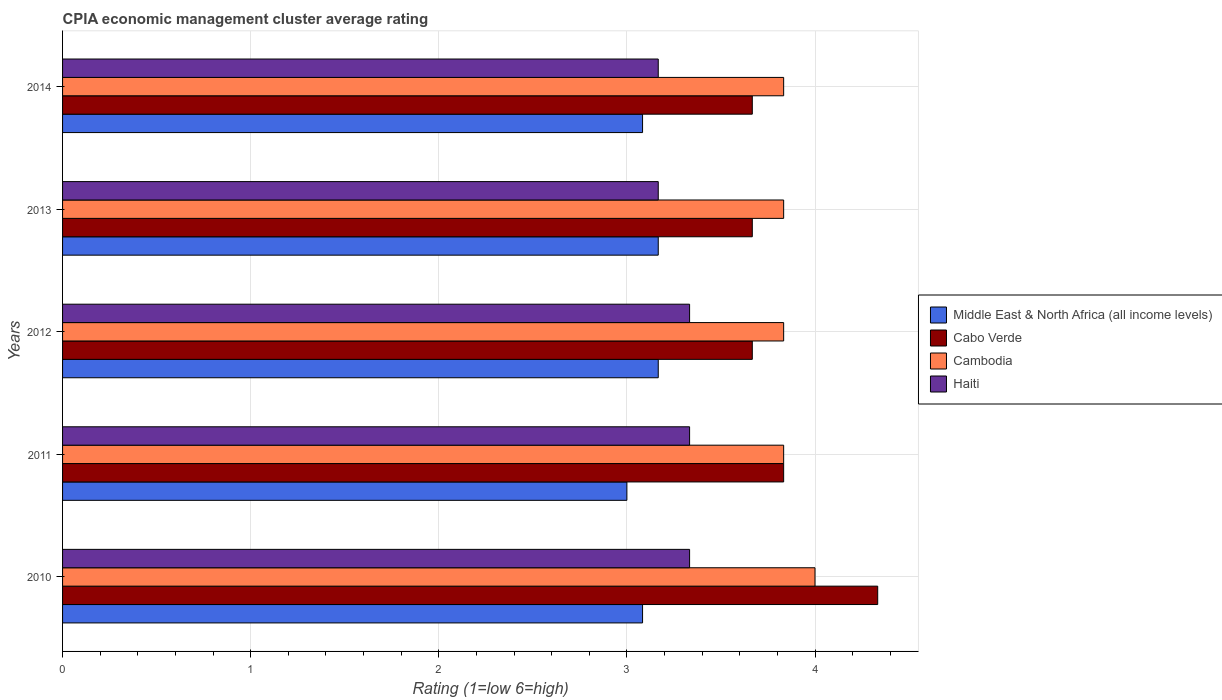Are the number of bars per tick equal to the number of legend labels?
Your answer should be very brief. Yes. Are the number of bars on each tick of the Y-axis equal?
Your answer should be very brief. Yes. How many bars are there on the 5th tick from the top?
Offer a very short reply. 4. How many bars are there on the 4th tick from the bottom?
Provide a succinct answer. 4. What is the label of the 4th group of bars from the top?
Offer a terse response. 2011. In how many cases, is the number of bars for a given year not equal to the number of legend labels?
Ensure brevity in your answer.  0. What is the CPIA rating in Middle East & North Africa (all income levels) in 2014?
Provide a succinct answer. 3.08. Across all years, what is the minimum CPIA rating in Middle East & North Africa (all income levels)?
Keep it short and to the point. 3. What is the total CPIA rating in Haiti in the graph?
Offer a very short reply. 16.33. What is the difference between the CPIA rating in Cabo Verde in 2013 and that in 2014?
Offer a terse response. 0. What is the difference between the CPIA rating in Cambodia in 2011 and the CPIA rating in Haiti in 2013?
Your response must be concise. 0.67. What is the average CPIA rating in Haiti per year?
Keep it short and to the point. 3.27. In the year 2010, what is the difference between the CPIA rating in Haiti and CPIA rating in Middle East & North Africa (all income levels)?
Your answer should be compact. 0.25. What is the ratio of the CPIA rating in Middle East & North Africa (all income levels) in 2010 to that in 2012?
Your answer should be very brief. 0.97. Is the CPIA rating in Haiti in 2010 less than that in 2013?
Offer a terse response. No. Is the difference between the CPIA rating in Haiti in 2010 and 2013 greater than the difference between the CPIA rating in Middle East & North Africa (all income levels) in 2010 and 2013?
Your response must be concise. Yes. What is the difference between the highest and the second highest CPIA rating in Cambodia?
Keep it short and to the point. 0.17. What is the difference between the highest and the lowest CPIA rating in Cabo Verde?
Give a very brief answer. 0.67. Is it the case that in every year, the sum of the CPIA rating in Haiti and CPIA rating in Cabo Verde is greater than the sum of CPIA rating in Cambodia and CPIA rating in Middle East & North Africa (all income levels)?
Your answer should be compact. Yes. What does the 3rd bar from the top in 2011 represents?
Make the answer very short. Cabo Verde. What does the 2nd bar from the bottom in 2014 represents?
Your response must be concise. Cabo Verde. How many bars are there?
Ensure brevity in your answer.  20. How many years are there in the graph?
Your answer should be compact. 5. What is the difference between two consecutive major ticks on the X-axis?
Keep it short and to the point. 1. Are the values on the major ticks of X-axis written in scientific E-notation?
Offer a terse response. No. Does the graph contain any zero values?
Give a very brief answer. No. How are the legend labels stacked?
Your response must be concise. Vertical. What is the title of the graph?
Offer a very short reply. CPIA economic management cluster average rating. Does "Albania" appear as one of the legend labels in the graph?
Offer a very short reply. No. What is the label or title of the Y-axis?
Keep it short and to the point. Years. What is the Rating (1=low 6=high) of Middle East & North Africa (all income levels) in 2010?
Ensure brevity in your answer.  3.08. What is the Rating (1=low 6=high) of Cabo Verde in 2010?
Provide a succinct answer. 4.33. What is the Rating (1=low 6=high) of Haiti in 2010?
Keep it short and to the point. 3.33. What is the Rating (1=low 6=high) in Middle East & North Africa (all income levels) in 2011?
Provide a short and direct response. 3. What is the Rating (1=low 6=high) of Cabo Verde in 2011?
Make the answer very short. 3.83. What is the Rating (1=low 6=high) of Cambodia in 2011?
Offer a terse response. 3.83. What is the Rating (1=low 6=high) of Haiti in 2011?
Ensure brevity in your answer.  3.33. What is the Rating (1=low 6=high) of Middle East & North Africa (all income levels) in 2012?
Your answer should be very brief. 3.17. What is the Rating (1=low 6=high) in Cabo Verde in 2012?
Provide a short and direct response. 3.67. What is the Rating (1=low 6=high) of Cambodia in 2012?
Your response must be concise. 3.83. What is the Rating (1=low 6=high) in Haiti in 2012?
Give a very brief answer. 3.33. What is the Rating (1=low 6=high) in Middle East & North Africa (all income levels) in 2013?
Ensure brevity in your answer.  3.17. What is the Rating (1=low 6=high) of Cabo Verde in 2013?
Keep it short and to the point. 3.67. What is the Rating (1=low 6=high) of Cambodia in 2013?
Offer a terse response. 3.83. What is the Rating (1=low 6=high) in Haiti in 2013?
Give a very brief answer. 3.17. What is the Rating (1=low 6=high) of Middle East & North Africa (all income levels) in 2014?
Keep it short and to the point. 3.08. What is the Rating (1=low 6=high) in Cabo Verde in 2014?
Offer a very short reply. 3.67. What is the Rating (1=low 6=high) in Cambodia in 2014?
Your answer should be compact. 3.83. What is the Rating (1=low 6=high) in Haiti in 2014?
Your response must be concise. 3.17. Across all years, what is the maximum Rating (1=low 6=high) of Middle East & North Africa (all income levels)?
Keep it short and to the point. 3.17. Across all years, what is the maximum Rating (1=low 6=high) of Cabo Verde?
Ensure brevity in your answer.  4.33. Across all years, what is the maximum Rating (1=low 6=high) in Haiti?
Provide a short and direct response. 3.33. Across all years, what is the minimum Rating (1=low 6=high) in Cabo Verde?
Give a very brief answer. 3.67. Across all years, what is the minimum Rating (1=low 6=high) in Cambodia?
Your answer should be compact. 3.83. Across all years, what is the minimum Rating (1=low 6=high) in Haiti?
Offer a terse response. 3.17. What is the total Rating (1=low 6=high) of Cabo Verde in the graph?
Offer a terse response. 19.17. What is the total Rating (1=low 6=high) in Cambodia in the graph?
Give a very brief answer. 19.33. What is the total Rating (1=low 6=high) of Haiti in the graph?
Make the answer very short. 16.33. What is the difference between the Rating (1=low 6=high) in Middle East & North Africa (all income levels) in 2010 and that in 2011?
Your answer should be compact. 0.08. What is the difference between the Rating (1=low 6=high) of Cabo Verde in 2010 and that in 2011?
Provide a short and direct response. 0.5. What is the difference between the Rating (1=low 6=high) in Cambodia in 2010 and that in 2011?
Provide a succinct answer. 0.17. What is the difference between the Rating (1=low 6=high) in Haiti in 2010 and that in 2011?
Offer a very short reply. 0. What is the difference between the Rating (1=low 6=high) in Middle East & North Africa (all income levels) in 2010 and that in 2012?
Make the answer very short. -0.08. What is the difference between the Rating (1=low 6=high) in Cabo Verde in 2010 and that in 2012?
Provide a succinct answer. 0.67. What is the difference between the Rating (1=low 6=high) of Cambodia in 2010 and that in 2012?
Provide a succinct answer. 0.17. What is the difference between the Rating (1=low 6=high) in Haiti in 2010 and that in 2012?
Make the answer very short. 0. What is the difference between the Rating (1=low 6=high) of Middle East & North Africa (all income levels) in 2010 and that in 2013?
Ensure brevity in your answer.  -0.08. What is the difference between the Rating (1=low 6=high) in Cabo Verde in 2010 and that in 2013?
Keep it short and to the point. 0.67. What is the difference between the Rating (1=low 6=high) of Haiti in 2010 and that in 2013?
Offer a very short reply. 0.17. What is the difference between the Rating (1=low 6=high) of Cambodia in 2010 and that in 2014?
Ensure brevity in your answer.  0.17. What is the difference between the Rating (1=low 6=high) of Haiti in 2010 and that in 2014?
Your answer should be very brief. 0.17. What is the difference between the Rating (1=low 6=high) in Cambodia in 2011 and that in 2012?
Offer a very short reply. 0. What is the difference between the Rating (1=low 6=high) of Haiti in 2011 and that in 2012?
Your response must be concise. 0. What is the difference between the Rating (1=low 6=high) in Cabo Verde in 2011 and that in 2013?
Offer a very short reply. 0.17. What is the difference between the Rating (1=low 6=high) of Cambodia in 2011 and that in 2013?
Your answer should be compact. 0. What is the difference between the Rating (1=low 6=high) in Middle East & North Africa (all income levels) in 2011 and that in 2014?
Offer a very short reply. -0.08. What is the difference between the Rating (1=low 6=high) of Cabo Verde in 2011 and that in 2014?
Offer a terse response. 0.17. What is the difference between the Rating (1=low 6=high) of Haiti in 2011 and that in 2014?
Provide a short and direct response. 0.17. What is the difference between the Rating (1=low 6=high) in Middle East & North Africa (all income levels) in 2012 and that in 2013?
Provide a succinct answer. 0. What is the difference between the Rating (1=low 6=high) in Cabo Verde in 2012 and that in 2013?
Offer a very short reply. 0. What is the difference between the Rating (1=low 6=high) in Haiti in 2012 and that in 2013?
Offer a terse response. 0.17. What is the difference between the Rating (1=low 6=high) in Middle East & North Africa (all income levels) in 2012 and that in 2014?
Your answer should be very brief. 0.08. What is the difference between the Rating (1=low 6=high) in Cabo Verde in 2012 and that in 2014?
Ensure brevity in your answer.  0. What is the difference between the Rating (1=low 6=high) of Haiti in 2012 and that in 2014?
Your answer should be very brief. 0.17. What is the difference between the Rating (1=low 6=high) of Middle East & North Africa (all income levels) in 2013 and that in 2014?
Your answer should be very brief. 0.08. What is the difference between the Rating (1=low 6=high) of Cambodia in 2013 and that in 2014?
Keep it short and to the point. 0. What is the difference between the Rating (1=low 6=high) of Haiti in 2013 and that in 2014?
Offer a terse response. -0. What is the difference between the Rating (1=low 6=high) in Middle East & North Africa (all income levels) in 2010 and the Rating (1=low 6=high) in Cabo Verde in 2011?
Ensure brevity in your answer.  -0.75. What is the difference between the Rating (1=low 6=high) in Middle East & North Africa (all income levels) in 2010 and the Rating (1=low 6=high) in Cambodia in 2011?
Your answer should be very brief. -0.75. What is the difference between the Rating (1=low 6=high) of Middle East & North Africa (all income levels) in 2010 and the Rating (1=low 6=high) of Haiti in 2011?
Keep it short and to the point. -0.25. What is the difference between the Rating (1=low 6=high) of Cabo Verde in 2010 and the Rating (1=low 6=high) of Cambodia in 2011?
Your answer should be compact. 0.5. What is the difference between the Rating (1=low 6=high) in Cabo Verde in 2010 and the Rating (1=low 6=high) in Haiti in 2011?
Keep it short and to the point. 1. What is the difference between the Rating (1=low 6=high) in Cambodia in 2010 and the Rating (1=low 6=high) in Haiti in 2011?
Your answer should be compact. 0.67. What is the difference between the Rating (1=low 6=high) of Middle East & North Africa (all income levels) in 2010 and the Rating (1=low 6=high) of Cabo Verde in 2012?
Provide a succinct answer. -0.58. What is the difference between the Rating (1=low 6=high) in Middle East & North Africa (all income levels) in 2010 and the Rating (1=low 6=high) in Cambodia in 2012?
Give a very brief answer. -0.75. What is the difference between the Rating (1=low 6=high) in Cabo Verde in 2010 and the Rating (1=low 6=high) in Cambodia in 2012?
Your response must be concise. 0.5. What is the difference between the Rating (1=low 6=high) of Cabo Verde in 2010 and the Rating (1=low 6=high) of Haiti in 2012?
Ensure brevity in your answer.  1. What is the difference between the Rating (1=low 6=high) in Cambodia in 2010 and the Rating (1=low 6=high) in Haiti in 2012?
Ensure brevity in your answer.  0.67. What is the difference between the Rating (1=low 6=high) of Middle East & North Africa (all income levels) in 2010 and the Rating (1=low 6=high) of Cabo Verde in 2013?
Keep it short and to the point. -0.58. What is the difference between the Rating (1=low 6=high) of Middle East & North Africa (all income levels) in 2010 and the Rating (1=low 6=high) of Cambodia in 2013?
Your response must be concise. -0.75. What is the difference between the Rating (1=low 6=high) of Middle East & North Africa (all income levels) in 2010 and the Rating (1=low 6=high) of Haiti in 2013?
Your answer should be compact. -0.08. What is the difference between the Rating (1=low 6=high) of Cabo Verde in 2010 and the Rating (1=low 6=high) of Cambodia in 2013?
Provide a short and direct response. 0.5. What is the difference between the Rating (1=low 6=high) in Cabo Verde in 2010 and the Rating (1=low 6=high) in Haiti in 2013?
Provide a succinct answer. 1.17. What is the difference between the Rating (1=low 6=high) in Cambodia in 2010 and the Rating (1=low 6=high) in Haiti in 2013?
Your response must be concise. 0.83. What is the difference between the Rating (1=low 6=high) of Middle East & North Africa (all income levels) in 2010 and the Rating (1=low 6=high) of Cabo Verde in 2014?
Make the answer very short. -0.58. What is the difference between the Rating (1=low 6=high) of Middle East & North Africa (all income levels) in 2010 and the Rating (1=low 6=high) of Cambodia in 2014?
Offer a very short reply. -0.75. What is the difference between the Rating (1=low 6=high) in Middle East & North Africa (all income levels) in 2010 and the Rating (1=low 6=high) in Haiti in 2014?
Provide a succinct answer. -0.08. What is the difference between the Rating (1=low 6=high) in Cabo Verde in 2010 and the Rating (1=low 6=high) in Cambodia in 2014?
Keep it short and to the point. 0.5. What is the difference between the Rating (1=low 6=high) in Cabo Verde in 2010 and the Rating (1=low 6=high) in Haiti in 2014?
Your answer should be compact. 1.17. What is the difference between the Rating (1=low 6=high) of Middle East & North Africa (all income levels) in 2011 and the Rating (1=low 6=high) of Cabo Verde in 2012?
Your answer should be compact. -0.67. What is the difference between the Rating (1=low 6=high) of Middle East & North Africa (all income levels) in 2011 and the Rating (1=low 6=high) of Cambodia in 2012?
Your response must be concise. -0.83. What is the difference between the Rating (1=low 6=high) in Middle East & North Africa (all income levels) in 2011 and the Rating (1=low 6=high) in Haiti in 2012?
Make the answer very short. -0.33. What is the difference between the Rating (1=low 6=high) of Cabo Verde in 2011 and the Rating (1=low 6=high) of Cambodia in 2012?
Offer a very short reply. 0. What is the difference between the Rating (1=low 6=high) of Cabo Verde in 2011 and the Rating (1=low 6=high) of Haiti in 2012?
Keep it short and to the point. 0.5. What is the difference between the Rating (1=low 6=high) in Cambodia in 2011 and the Rating (1=low 6=high) in Haiti in 2012?
Your answer should be very brief. 0.5. What is the difference between the Rating (1=low 6=high) of Middle East & North Africa (all income levels) in 2011 and the Rating (1=low 6=high) of Cambodia in 2013?
Offer a terse response. -0.83. What is the difference between the Rating (1=low 6=high) of Middle East & North Africa (all income levels) in 2011 and the Rating (1=low 6=high) of Haiti in 2013?
Make the answer very short. -0.17. What is the difference between the Rating (1=low 6=high) of Middle East & North Africa (all income levels) in 2011 and the Rating (1=low 6=high) of Cabo Verde in 2014?
Offer a terse response. -0.67. What is the difference between the Rating (1=low 6=high) of Middle East & North Africa (all income levels) in 2011 and the Rating (1=low 6=high) of Haiti in 2014?
Provide a succinct answer. -0.17. What is the difference between the Rating (1=low 6=high) in Cabo Verde in 2011 and the Rating (1=low 6=high) in Haiti in 2014?
Provide a short and direct response. 0.67. What is the difference between the Rating (1=low 6=high) in Middle East & North Africa (all income levels) in 2012 and the Rating (1=low 6=high) in Cabo Verde in 2013?
Your answer should be very brief. -0.5. What is the difference between the Rating (1=low 6=high) of Cabo Verde in 2012 and the Rating (1=low 6=high) of Haiti in 2013?
Your response must be concise. 0.5. What is the difference between the Rating (1=low 6=high) of Cambodia in 2012 and the Rating (1=low 6=high) of Haiti in 2013?
Provide a short and direct response. 0.67. What is the difference between the Rating (1=low 6=high) in Middle East & North Africa (all income levels) in 2012 and the Rating (1=low 6=high) in Cabo Verde in 2014?
Your answer should be very brief. -0.5. What is the difference between the Rating (1=low 6=high) of Cabo Verde in 2012 and the Rating (1=low 6=high) of Cambodia in 2014?
Offer a terse response. -0.17. What is the difference between the Rating (1=low 6=high) in Cambodia in 2012 and the Rating (1=low 6=high) in Haiti in 2014?
Your response must be concise. 0.67. What is the difference between the Rating (1=low 6=high) of Middle East & North Africa (all income levels) in 2013 and the Rating (1=low 6=high) of Cambodia in 2014?
Your answer should be very brief. -0.67. What is the average Rating (1=low 6=high) in Cabo Verde per year?
Give a very brief answer. 3.83. What is the average Rating (1=low 6=high) of Cambodia per year?
Offer a very short reply. 3.87. What is the average Rating (1=low 6=high) in Haiti per year?
Ensure brevity in your answer.  3.27. In the year 2010, what is the difference between the Rating (1=low 6=high) in Middle East & North Africa (all income levels) and Rating (1=low 6=high) in Cabo Verde?
Ensure brevity in your answer.  -1.25. In the year 2010, what is the difference between the Rating (1=low 6=high) of Middle East & North Africa (all income levels) and Rating (1=low 6=high) of Cambodia?
Give a very brief answer. -0.92. In the year 2010, what is the difference between the Rating (1=low 6=high) in Middle East & North Africa (all income levels) and Rating (1=low 6=high) in Haiti?
Ensure brevity in your answer.  -0.25. In the year 2010, what is the difference between the Rating (1=low 6=high) of Cabo Verde and Rating (1=low 6=high) of Cambodia?
Your answer should be compact. 0.33. In the year 2010, what is the difference between the Rating (1=low 6=high) in Cabo Verde and Rating (1=low 6=high) in Haiti?
Ensure brevity in your answer.  1. In the year 2011, what is the difference between the Rating (1=low 6=high) of Middle East & North Africa (all income levels) and Rating (1=low 6=high) of Cambodia?
Your response must be concise. -0.83. In the year 2011, what is the difference between the Rating (1=low 6=high) of Middle East & North Africa (all income levels) and Rating (1=low 6=high) of Haiti?
Provide a succinct answer. -0.33. In the year 2011, what is the difference between the Rating (1=low 6=high) of Cabo Verde and Rating (1=low 6=high) of Cambodia?
Your answer should be very brief. 0. In the year 2011, what is the difference between the Rating (1=low 6=high) in Cabo Verde and Rating (1=low 6=high) in Haiti?
Offer a terse response. 0.5. In the year 2011, what is the difference between the Rating (1=low 6=high) in Cambodia and Rating (1=low 6=high) in Haiti?
Provide a short and direct response. 0.5. In the year 2013, what is the difference between the Rating (1=low 6=high) of Middle East & North Africa (all income levels) and Rating (1=low 6=high) of Haiti?
Keep it short and to the point. 0. In the year 2013, what is the difference between the Rating (1=low 6=high) in Cabo Verde and Rating (1=low 6=high) in Cambodia?
Offer a very short reply. -0.17. In the year 2013, what is the difference between the Rating (1=low 6=high) in Cambodia and Rating (1=low 6=high) in Haiti?
Give a very brief answer. 0.67. In the year 2014, what is the difference between the Rating (1=low 6=high) in Middle East & North Africa (all income levels) and Rating (1=low 6=high) in Cabo Verde?
Give a very brief answer. -0.58. In the year 2014, what is the difference between the Rating (1=low 6=high) in Middle East & North Africa (all income levels) and Rating (1=low 6=high) in Cambodia?
Provide a succinct answer. -0.75. In the year 2014, what is the difference between the Rating (1=low 6=high) in Middle East & North Africa (all income levels) and Rating (1=low 6=high) in Haiti?
Ensure brevity in your answer.  -0.08. In the year 2014, what is the difference between the Rating (1=low 6=high) in Cabo Verde and Rating (1=low 6=high) in Haiti?
Your response must be concise. 0.5. In the year 2014, what is the difference between the Rating (1=low 6=high) of Cambodia and Rating (1=low 6=high) of Haiti?
Your answer should be compact. 0.67. What is the ratio of the Rating (1=low 6=high) of Middle East & North Africa (all income levels) in 2010 to that in 2011?
Keep it short and to the point. 1.03. What is the ratio of the Rating (1=low 6=high) in Cabo Verde in 2010 to that in 2011?
Your answer should be compact. 1.13. What is the ratio of the Rating (1=low 6=high) in Cambodia in 2010 to that in 2011?
Give a very brief answer. 1.04. What is the ratio of the Rating (1=low 6=high) of Haiti in 2010 to that in 2011?
Ensure brevity in your answer.  1. What is the ratio of the Rating (1=low 6=high) in Middle East & North Africa (all income levels) in 2010 to that in 2012?
Give a very brief answer. 0.97. What is the ratio of the Rating (1=low 6=high) of Cabo Verde in 2010 to that in 2012?
Your answer should be very brief. 1.18. What is the ratio of the Rating (1=low 6=high) in Cambodia in 2010 to that in 2012?
Provide a succinct answer. 1.04. What is the ratio of the Rating (1=low 6=high) in Middle East & North Africa (all income levels) in 2010 to that in 2013?
Make the answer very short. 0.97. What is the ratio of the Rating (1=low 6=high) in Cabo Verde in 2010 to that in 2013?
Your answer should be very brief. 1.18. What is the ratio of the Rating (1=low 6=high) in Cambodia in 2010 to that in 2013?
Give a very brief answer. 1.04. What is the ratio of the Rating (1=low 6=high) in Haiti in 2010 to that in 2013?
Your answer should be very brief. 1.05. What is the ratio of the Rating (1=low 6=high) in Middle East & North Africa (all income levels) in 2010 to that in 2014?
Ensure brevity in your answer.  1. What is the ratio of the Rating (1=low 6=high) of Cabo Verde in 2010 to that in 2014?
Give a very brief answer. 1.18. What is the ratio of the Rating (1=low 6=high) of Cambodia in 2010 to that in 2014?
Provide a short and direct response. 1.04. What is the ratio of the Rating (1=low 6=high) of Haiti in 2010 to that in 2014?
Your answer should be compact. 1.05. What is the ratio of the Rating (1=low 6=high) in Cabo Verde in 2011 to that in 2012?
Make the answer very short. 1.05. What is the ratio of the Rating (1=low 6=high) of Cabo Verde in 2011 to that in 2013?
Provide a succinct answer. 1.05. What is the ratio of the Rating (1=low 6=high) of Haiti in 2011 to that in 2013?
Your answer should be compact. 1.05. What is the ratio of the Rating (1=low 6=high) of Cabo Verde in 2011 to that in 2014?
Ensure brevity in your answer.  1.05. What is the ratio of the Rating (1=low 6=high) in Cambodia in 2011 to that in 2014?
Offer a terse response. 1. What is the ratio of the Rating (1=low 6=high) of Haiti in 2011 to that in 2014?
Your response must be concise. 1.05. What is the ratio of the Rating (1=low 6=high) in Cambodia in 2012 to that in 2013?
Provide a short and direct response. 1. What is the ratio of the Rating (1=low 6=high) of Haiti in 2012 to that in 2013?
Offer a very short reply. 1.05. What is the ratio of the Rating (1=low 6=high) in Middle East & North Africa (all income levels) in 2012 to that in 2014?
Your answer should be compact. 1.03. What is the ratio of the Rating (1=low 6=high) in Cabo Verde in 2012 to that in 2014?
Offer a terse response. 1. What is the ratio of the Rating (1=low 6=high) of Cambodia in 2012 to that in 2014?
Make the answer very short. 1. What is the ratio of the Rating (1=low 6=high) of Haiti in 2012 to that in 2014?
Offer a very short reply. 1.05. What is the ratio of the Rating (1=low 6=high) in Middle East & North Africa (all income levels) in 2013 to that in 2014?
Provide a short and direct response. 1.03. What is the ratio of the Rating (1=low 6=high) in Cambodia in 2013 to that in 2014?
Your response must be concise. 1. What is the difference between the highest and the second highest Rating (1=low 6=high) in Middle East & North Africa (all income levels)?
Your answer should be compact. 0. What is the difference between the highest and the lowest Rating (1=low 6=high) in Middle East & North Africa (all income levels)?
Keep it short and to the point. 0.17. What is the difference between the highest and the lowest Rating (1=low 6=high) of Cabo Verde?
Make the answer very short. 0.67. What is the difference between the highest and the lowest Rating (1=low 6=high) in Cambodia?
Your response must be concise. 0.17. 